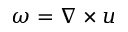Convert formula to latex. <formula><loc_0><loc_0><loc_500><loc_500>\omega = \nabla \times u</formula> 